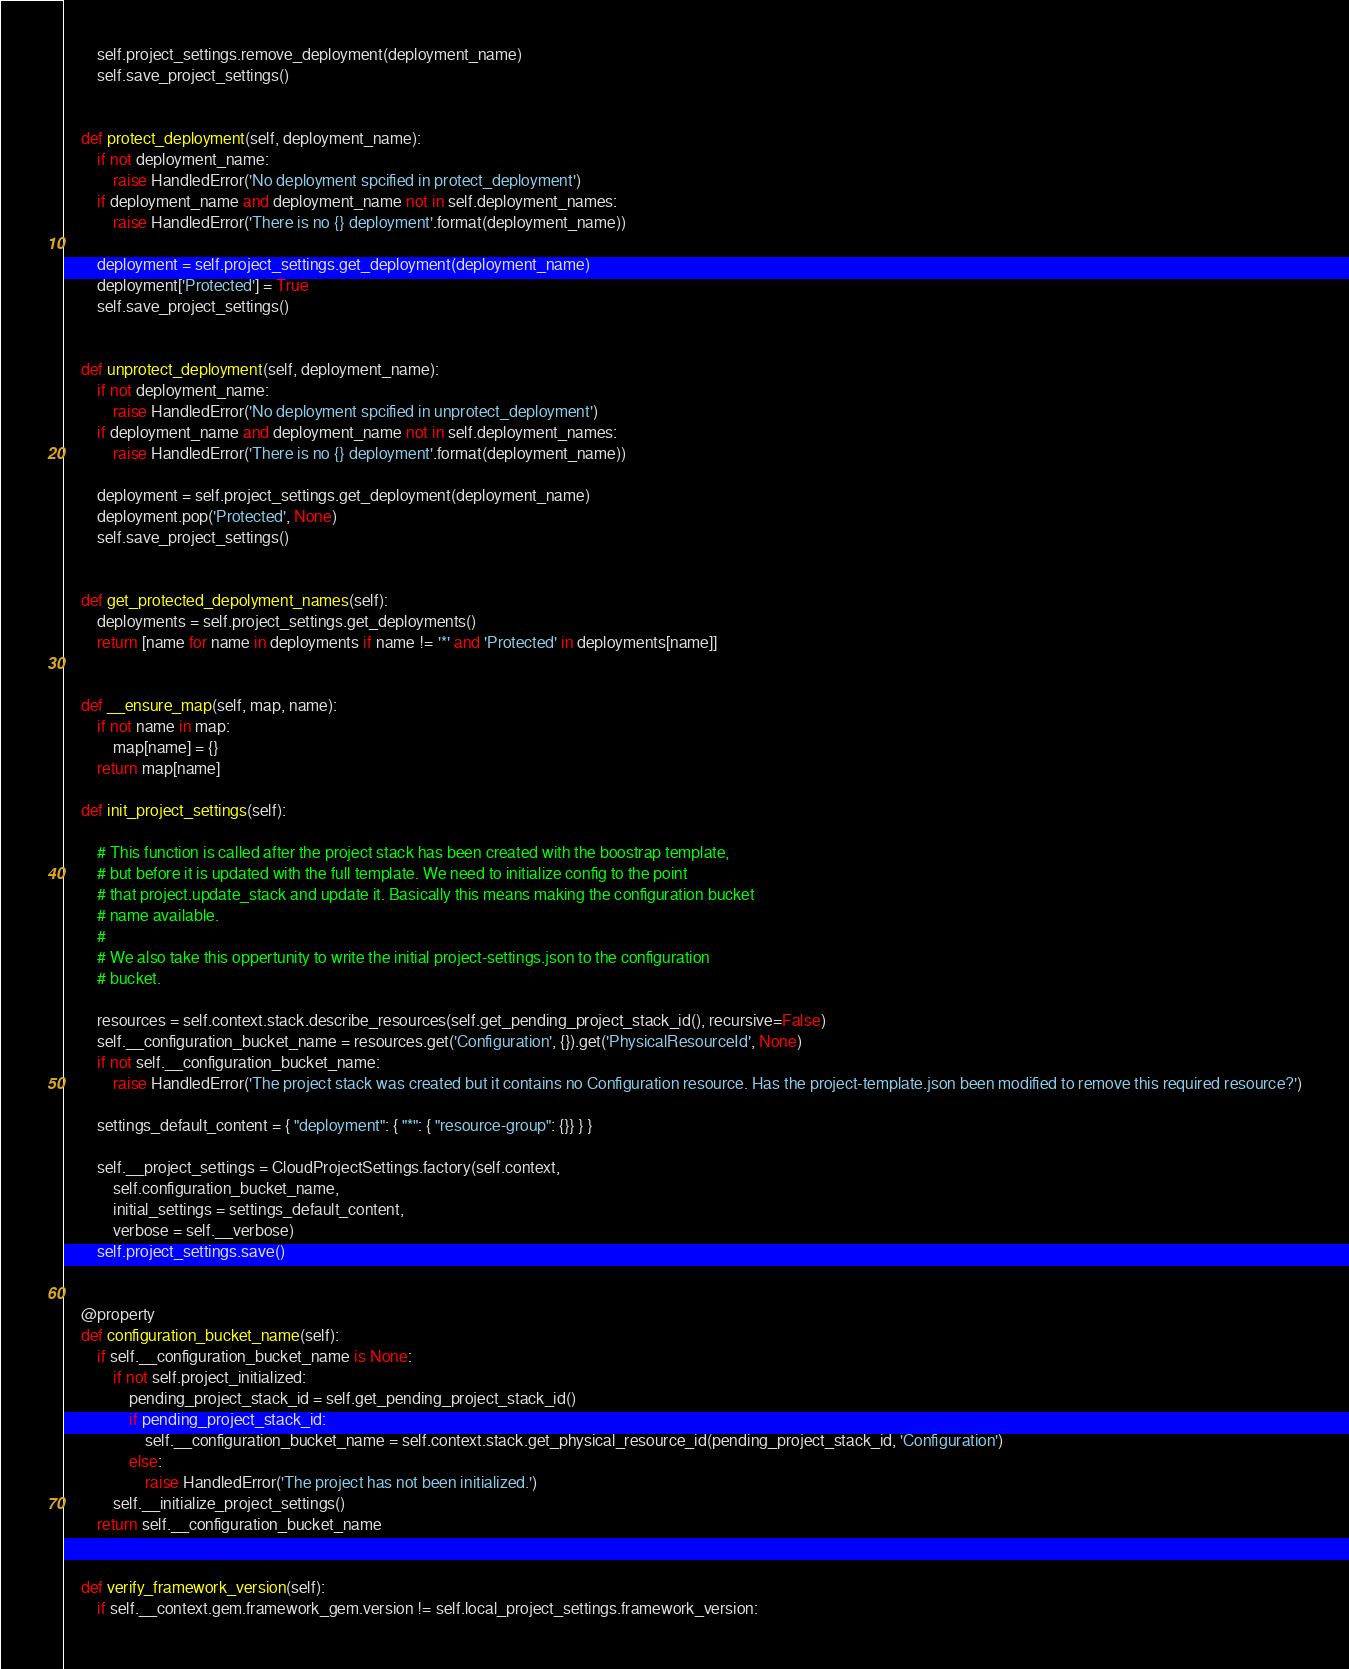Convert code to text. <code><loc_0><loc_0><loc_500><loc_500><_Python_>        self.project_settings.remove_deployment(deployment_name)
        self.save_project_settings()


    def protect_deployment(self, deployment_name):
        if not deployment_name:
            raise HandledError('No deployment spcified in protect_deployment')
        if deployment_name and deployment_name not in self.deployment_names:
            raise HandledError('There is no {} deployment'.format(deployment_name))

        deployment = self.project_settings.get_deployment(deployment_name)
        deployment['Protected'] = True
        self.save_project_settings()


    def unprotect_deployment(self, deployment_name):
        if not deployment_name:
            raise HandledError('No deployment spcified in unprotect_deployment')
        if deployment_name and deployment_name not in self.deployment_names:
            raise HandledError('There is no {} deployment'.format(deployment_name))

        deployment = self.project_settings.get_deployment(deployment_name)
        deployment.pop('Protected', None)
        self.save_project_settings()


    def get_protected_depolyment_names(self):
        deployments = self.project_settings.get_deployments()
        return [name for name in deployments if name != '*' and 'Protected' in deployments[name]]


    def __ensure_map(self, map, name):
        if not name in map:
            map[name] = {}
        return map[name]

    def init_project_settings(self):

        # This function is called after the project stack has been created with the boostrap template, 
        # but before it is updated with the full template. We need to initialize config to the point
        # that project.update_stack and update it. Basically this means making the configuration bucket
        # name available. 
        #
        # We also take this oppertunity to write the initial project-settings.json to the configuration
        # bucket.

        resources = self.context.stack.describe_resources(self.get_pending_project_stack_id(), recursive=False)
        self.__configuration_bucket_name = resources.get('Configuration', {}).get('PhysicalResourceId', None)
        if not self.__configuration_bucket_name:
            raise HandledError('The project stack was created but it contains no Configuration resource. Has the project-template.json been modified to remove this required resource?')

        settings_default_content = { "deployment": { "*": { "resource-group": {}} } }

        self.__project_settings = CloudProjectSettings.factory(self.context, 
            self.configuration_bucket_name, 
            initial_settings = settings_default_content, 
            verbose = self.__verbose)
        self.project_settings.save()


    @property
    def configuration_bucket_name(self):
        if self.__configuration_bucket_name is None:
            if not self.project_initialized:
                pending_project_stack_id = self.get_pending_project_stack_id()
                if pending_project_stack_id:
                    self.__configuration_bucket_name = self.context.stack.get_physical_resource_id(pending_project_stack_id, 'Configuration')
                else:
                    raise HandledError('The project has not been initialized.')
            self.__initialize_project_settings()
        return self.__configuration_bucket_name


    def verify_framework_version(self):        
        if self.__context.gem.framework_gem.version != self.local_project_settings.framework_version:</code> 